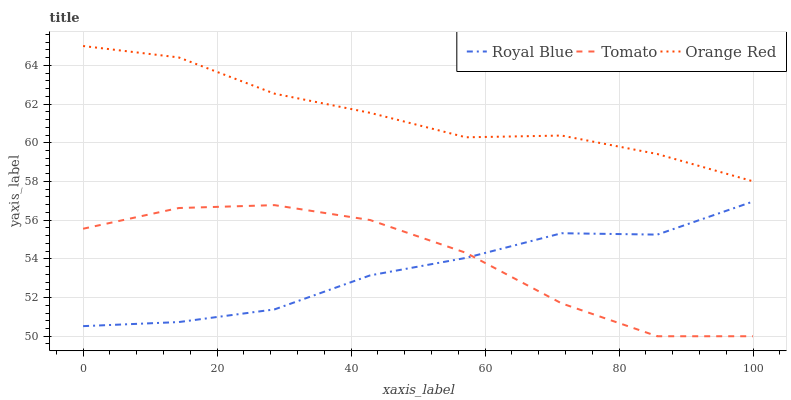Does Royal Blue have the minimum area under the curve?
Answer yes or no. Yes. Does Orange Red have the maximum area under the curve?
Answer yes or no. Yes. Does Orange Red have the minimum area under the curve?
Answer yes or no. No. Does Royal Blue have the maximum area under the curve?
Answer yes or no. No. Is Orange Red the smoothest?
Answer yes or no. Yes. Is Tomato the roughest?
Answer yes or no. Yes. Is Royal Blue the smoothest?
Answer yes or no. No. Is Royal Blue the roughest?
Answer yes or no. No. Does Tomato have the lowest value?
Answer yes or no. Yes. Does Royal Blue have the lowest value?
Answer yes or no. No. Does Orange Red have the highest value?
Answer yes or no. Yes. Does Royal Blue have the highest value?
Answer yes or no. No. Is Royal Blue less than Orange Red?
Answer yes or no. Yes. Is Orange Red greater than Tomato?
Answer yes or no. Yes. Does Tomato intersect Royal Blue?
Answer yes or no. Yes. Is Tomato less than Royal Blue?
Answer yes or no. No. Is Tomato greater than Royal Blue?
Answer yes or no. No. Does Royal Blue intersect Orange Red?
Answer yes or no. No. 